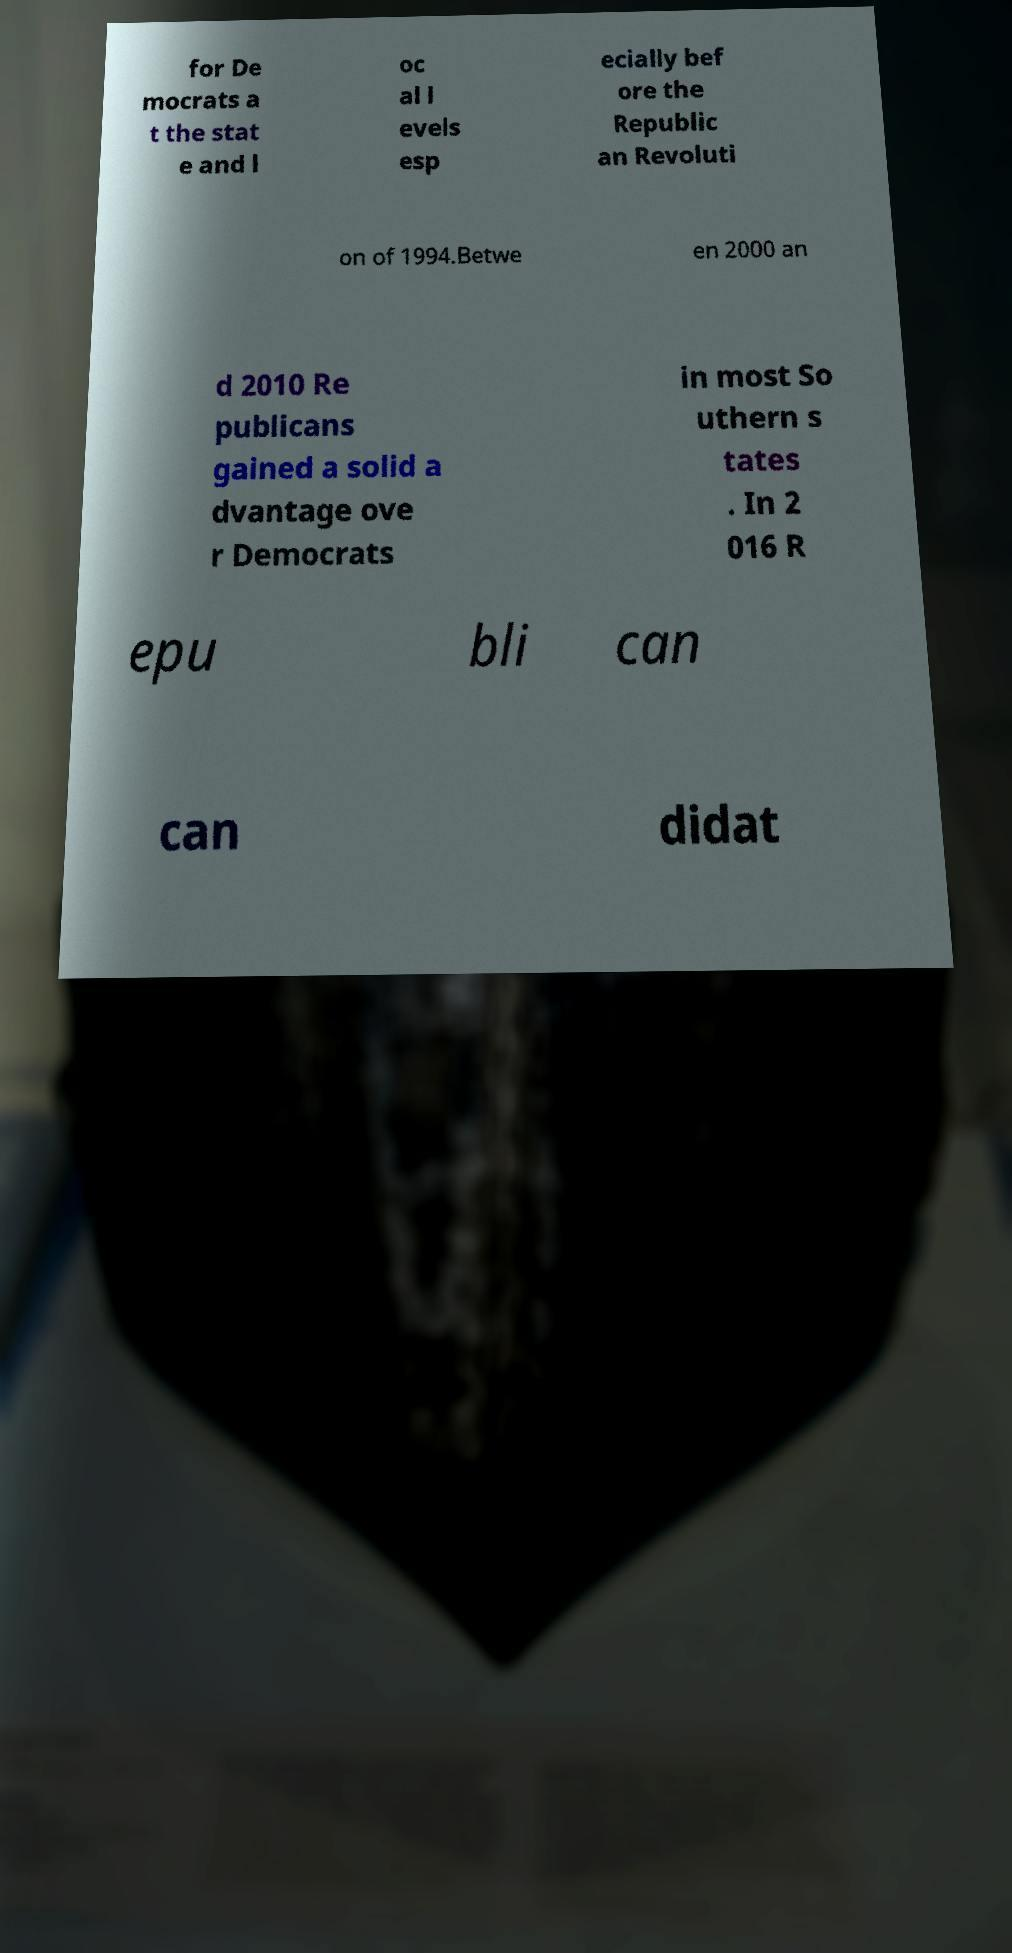Could you assist in decoding the text presented in this image and type it out clearly? for De mocrats a t the stat e and l oc al l evels esp ecially bef ore the Republic an Revoluti on of 1994.Betwe en 2000 an d 2010 Re publicans gained a solid a dvantage ove r Democrats in most So uthern s tates . In 2 016 R epu bli can can didat 